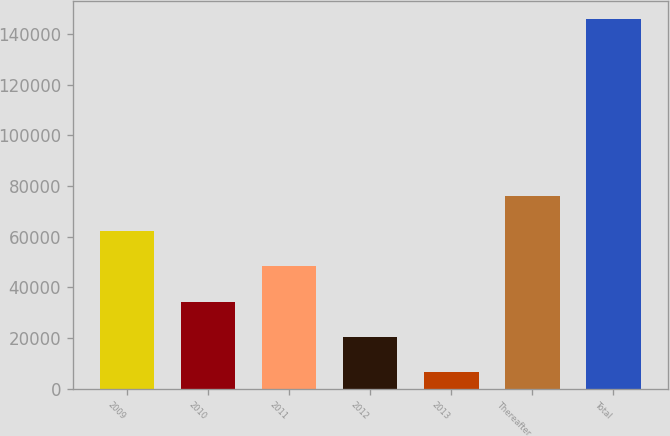<chart> <loc_0><loc_0><loc_500><loc_500><bar_chart><fcel>2009<fcel>2010<fcel>2011<fcel>2012<fcel>2013<fcel>Thereafter<fcel>Total<nl><fcel>62312<fcel>34447<fcel>48379.5<fcel>20514.5<fcel>6582<fcel>76244.5<fcel>145907<nl></chart> 